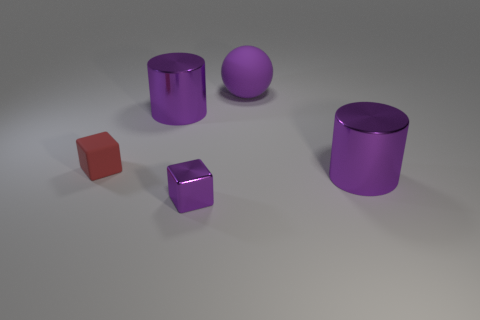What shape is the small object that is the same color as the matte sphere?
Ensure brevity in your answer.  Cube. What is the size of the shiny block that is the same color as the sphere?
Offer a very short reply. Small. There is a cube that is the same color as the big matte ball; what is it made of?
Make the answer very short. Metal. Do the purple shiny block and the matte sphere have the same size?
Keep it short and to the point. No. There is a object that is both on the right side of the red object and on the left side of the small purple metal object; how big is it?
Ensure brevity in your answer.  Large. How many matte objects are balls or large cylinders?
Your answer should be very brief. 1. Is the number of big cylinders that are behind the shiny cube greater than the number of red rubber cylinders?
Make the answer very short. Yes. What is the cylinder in front of the small rubber thing made of?
Your response must be concise. Metal. How many large purple balls have the same material as the tiny purple thing?
Your answer should be very brief. 0. There is a large purple thing that is to the right of the metal cube and behind the red rubber block; what shape is it?
Offer a terse response. Sphere. 